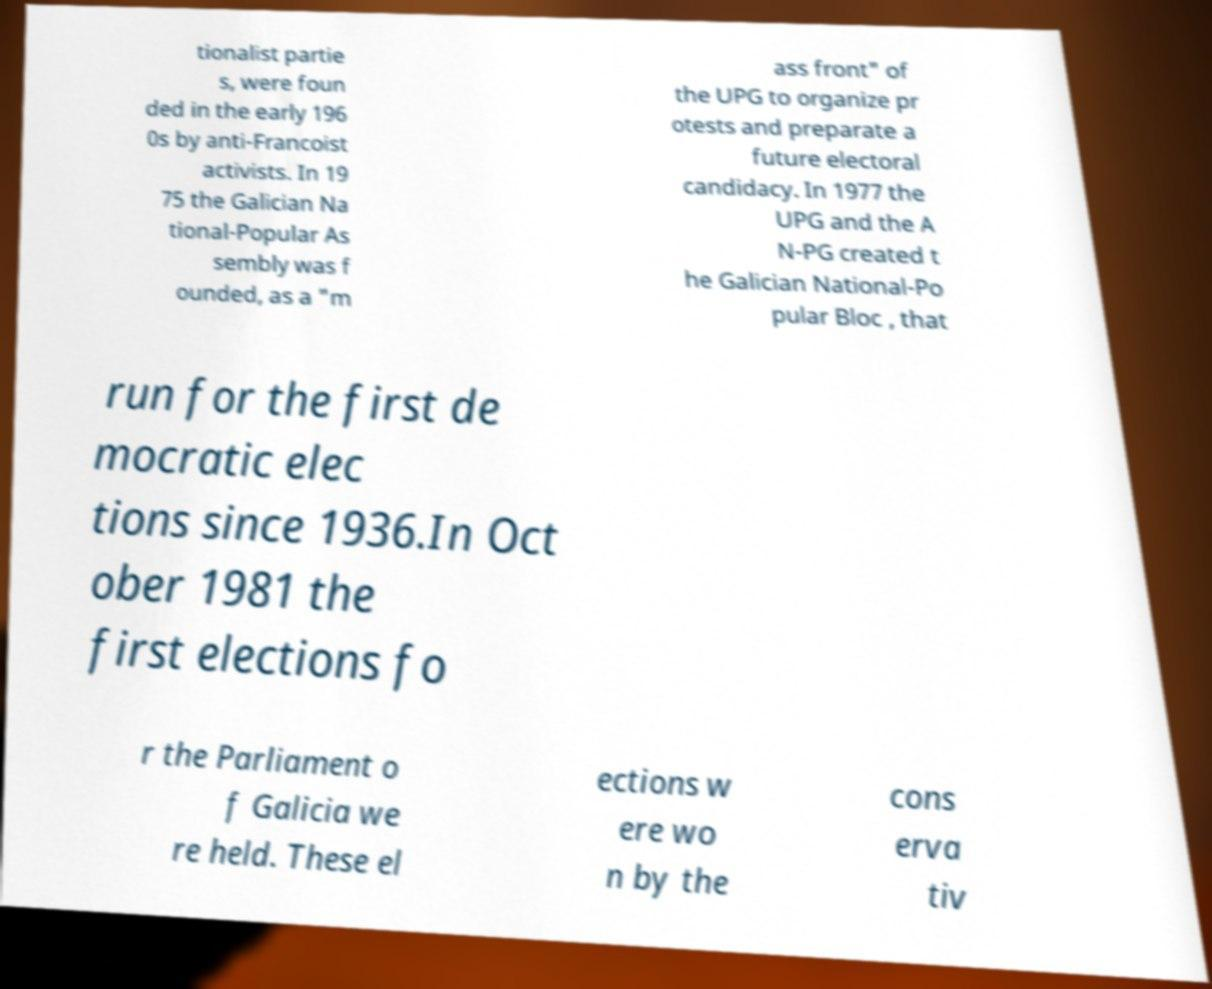Please identify and transcribe the text found in this image. tionalist partie s, were foun ded in the early 196 0s by anti-Francoist activists. In 19 75 the Galician Na tional-Popular As sembly was f ounded, as a "m ass front" of the UPG to organize pr otests and preparate a future electoral candidacy. In 1977 the UPG and the A N-PG created t he Galician National-Po pular Bloc , that run for the first de mocratic elec tions since 1936.In Oct ober 1981 the first elections fo r the Parliament o f Galicia we re held. These el ections w ere wo n by the cons erva tiv 